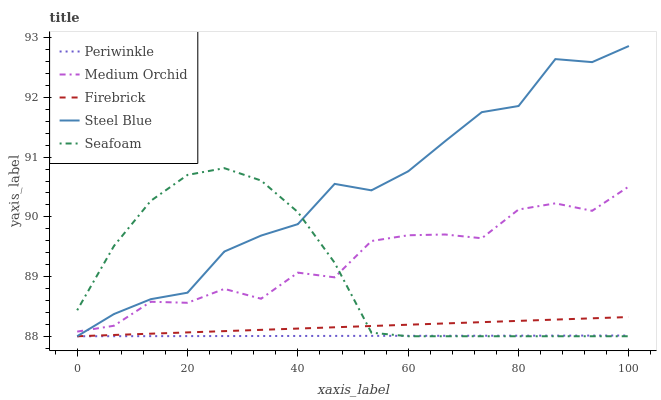Does Medium Orchid have the minimum area under the curve?
Answer yes or no. No. Does Medium Orchid have the maximum area under the curve?
Answer yes or no. No. Is Medium Orchid the smoothest?
Answer yes or no. No. Is Periwinkle the roughest?
Answer yes or no. No. Does Medium Orchid have the lowest value?
Answer yes or no. No. Does Medium Orchid have the highest value?
Answer yes or no. No. Is Firebrick less than Medium Orchid?
Answer yes or no. Yes. Is Medium Orchid greater than Periwinkle?
Answer yes or no. Yes. Does Firebrick intersect Medium Orchid?
Answer yes or no. No. 